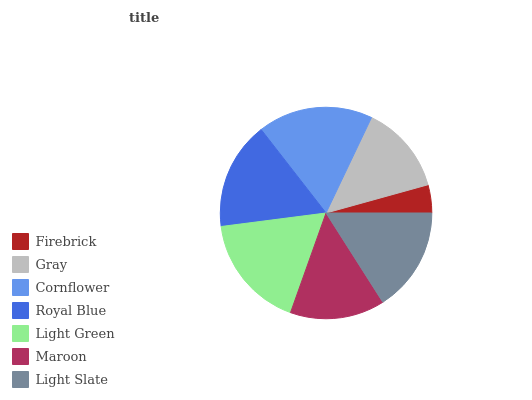Is Firebrick the minimum?
Answer yes or no. Yes. Is Cornflower the maximum?
Answer yes or no. Yes. Is Gray the minimum?
Answer yes or no. No. Is Gray the maximum?
Answer yes or no. No. Is Gray greater than Firebrick?
Answer yes or no. Yes. Is Firebrick less than Gray?
Answer yes or no. Yes. Is Firebrick greater than Gray?
Answer yes or no. No. Is Gray less than Firebrick?
Answer yes or no. No. Is Light Slate the high median?
Answer yes or no. Yes. Is Light Slate the low median?
Answer yes or no. Yes. Is Cornflower the high median?
Answer yes or no. No. Is Light Green the low median?
Answer yes or no. No. 